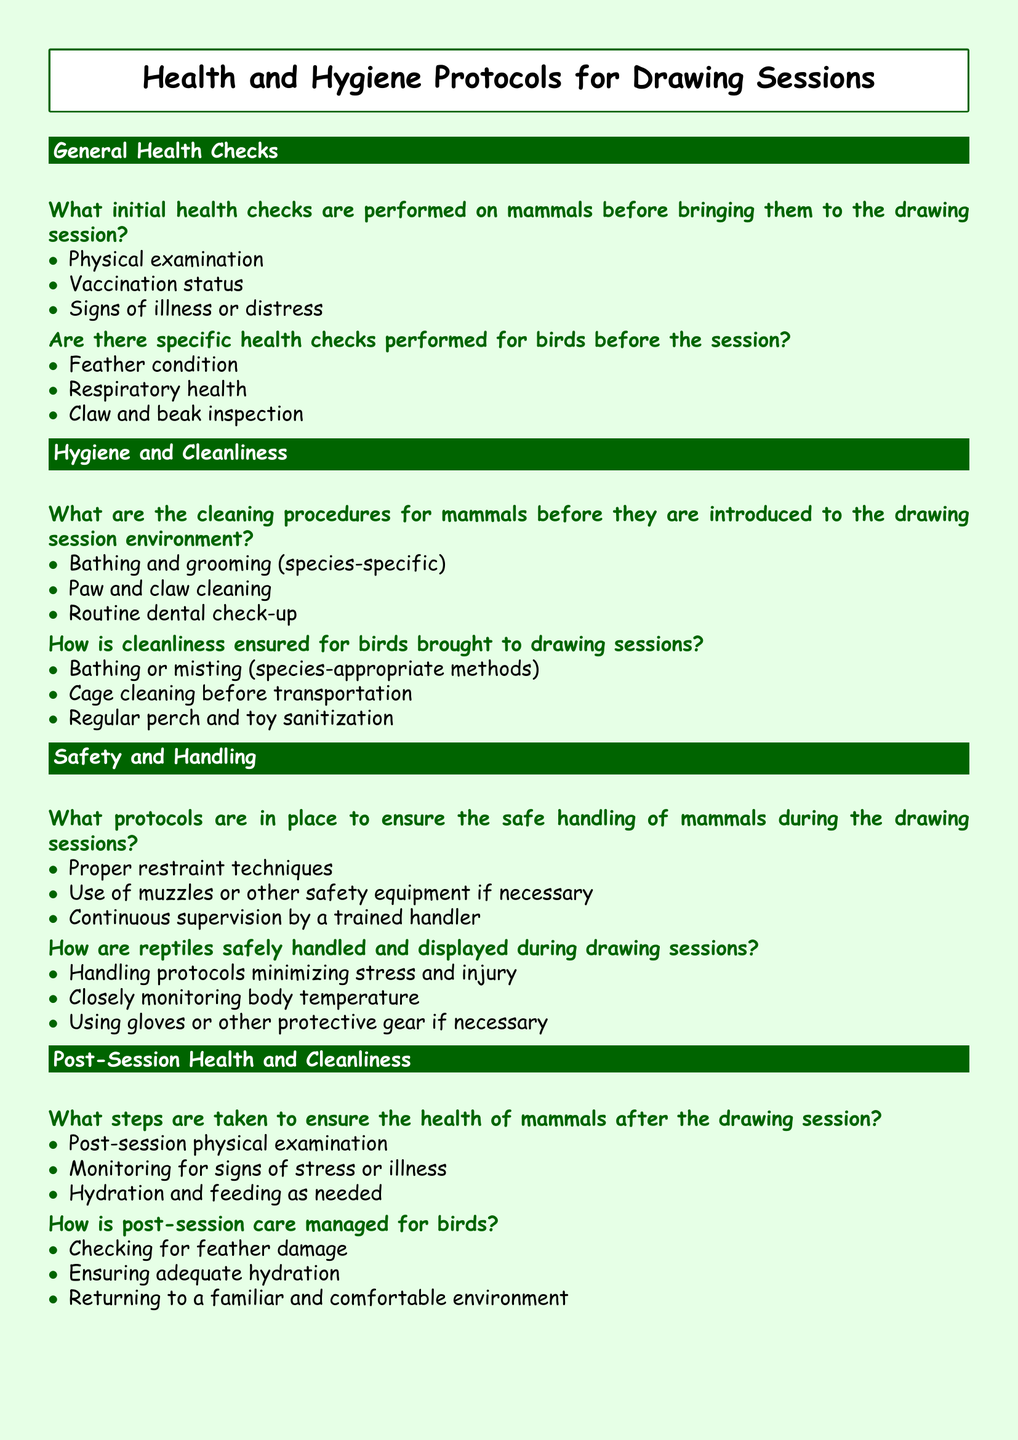What initial health checks are performed on mammals? The document specifies three initial health checks performed on mammals, namely physical examination, vaccination status, and signs of illness or distress.
Answer: Physical examination, vaccination status, signs of illness or distress What cleaning procedures are mentioned for mammals? The document outlines three cleaning procedures for mammals, which include bathing and grooming, paw and claw cleaning, and routine dental check-up.
Answer: Bathing and grooming, paw and claw cleaning, routine dental check-up What will be checked for bird cleanliness? The document lists three procedures to ensure cleanliness for birds: bathing or misting, cage cleaning before transportation, and regular perch and toy sanitization.
Answer: Bathing or misting, cage cleaning before transportation, regular perch and toy sanitization What is done post-session for mammal health? For mammal health post-session, physical examination, monitoring for signs of stress or illness, and hydration and feeding are conducted.
Answer: Post-session physical examination, monitoring for signs of stress or illness, hydration and feeding How is hydration ensured for birds post-session? The document indicates that ensuring adequate hydration is a step taken after the drawing session for birds.
Answer: Ensuring adequate hydration 